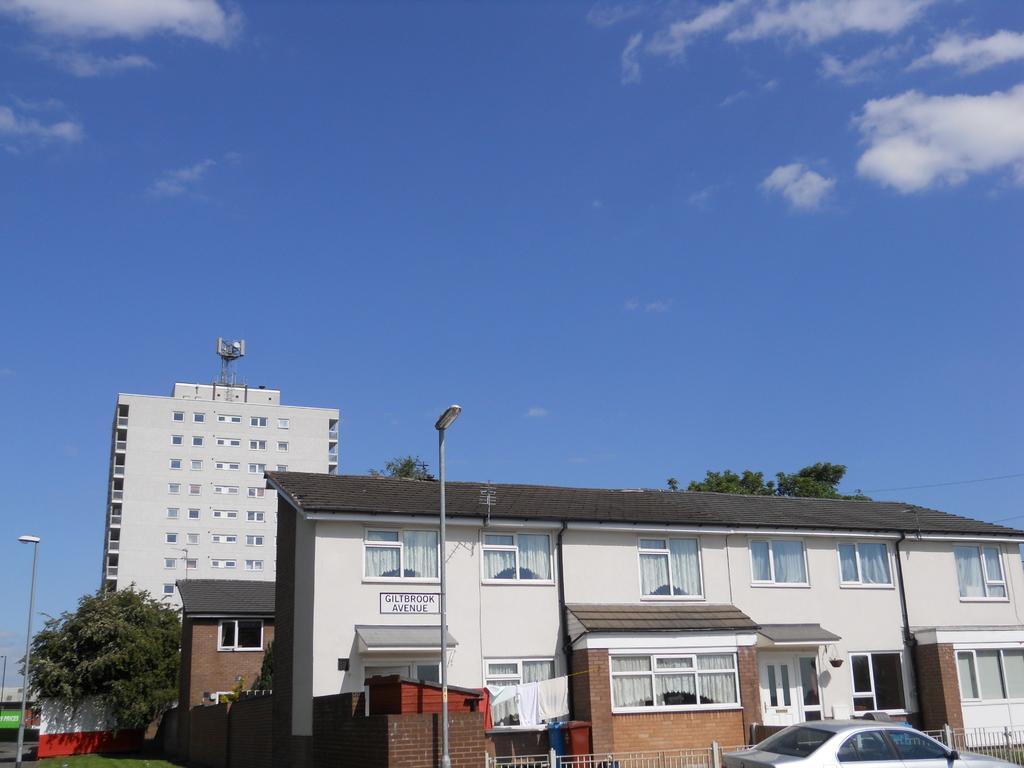Please provide a concise description of this image. In this image we can see buildings, sheds, clothes hanged on the rope, trees, street poles, street lights, railings, motor vehicle on the road and sky with clouds in the background. 